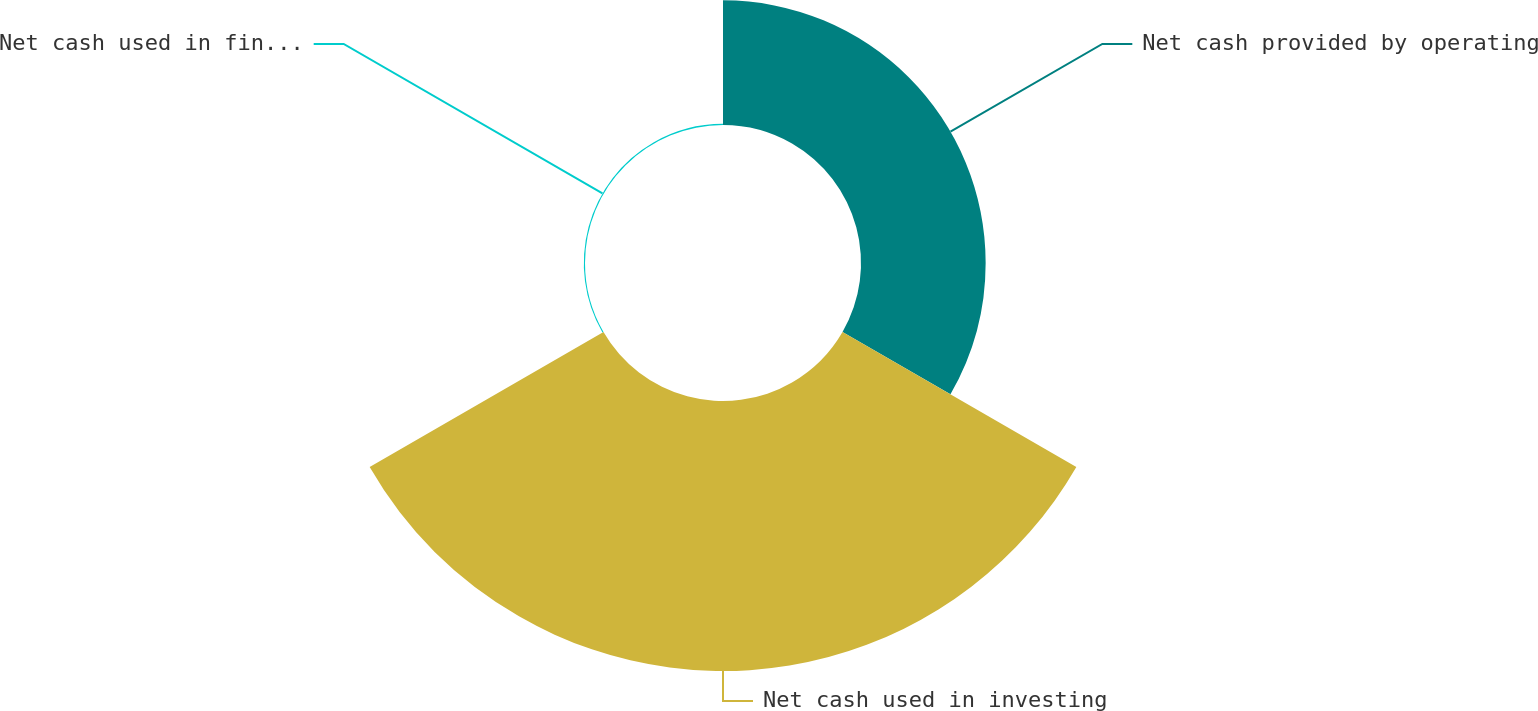Convert chart. <chart><loc_0><loc_0><loc_500><loc_500><pie_chart><fcel>Net cash provided by operating<fcel>Net cash used in investing<fcel>Net cash used in financing<nl><fcel>31.49%<fcel>68.21%<fcel>0.3%<nl></chart> 